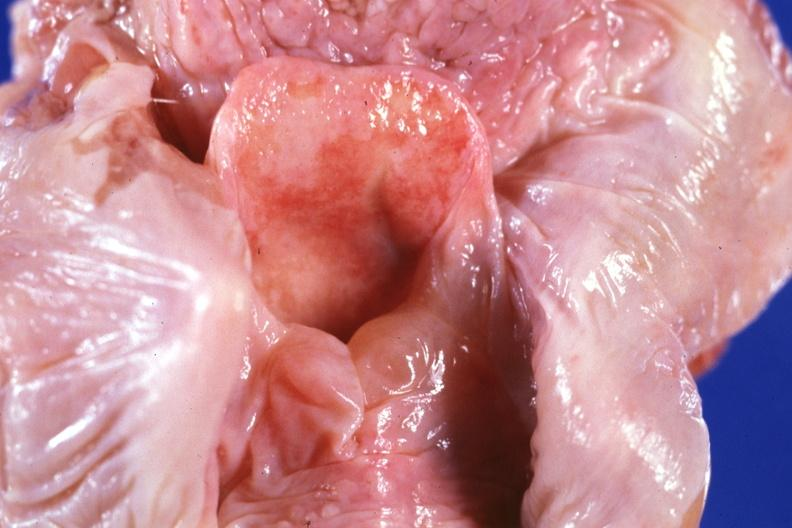s larynx present?
Answer the question using a single word or phrase. Yes 